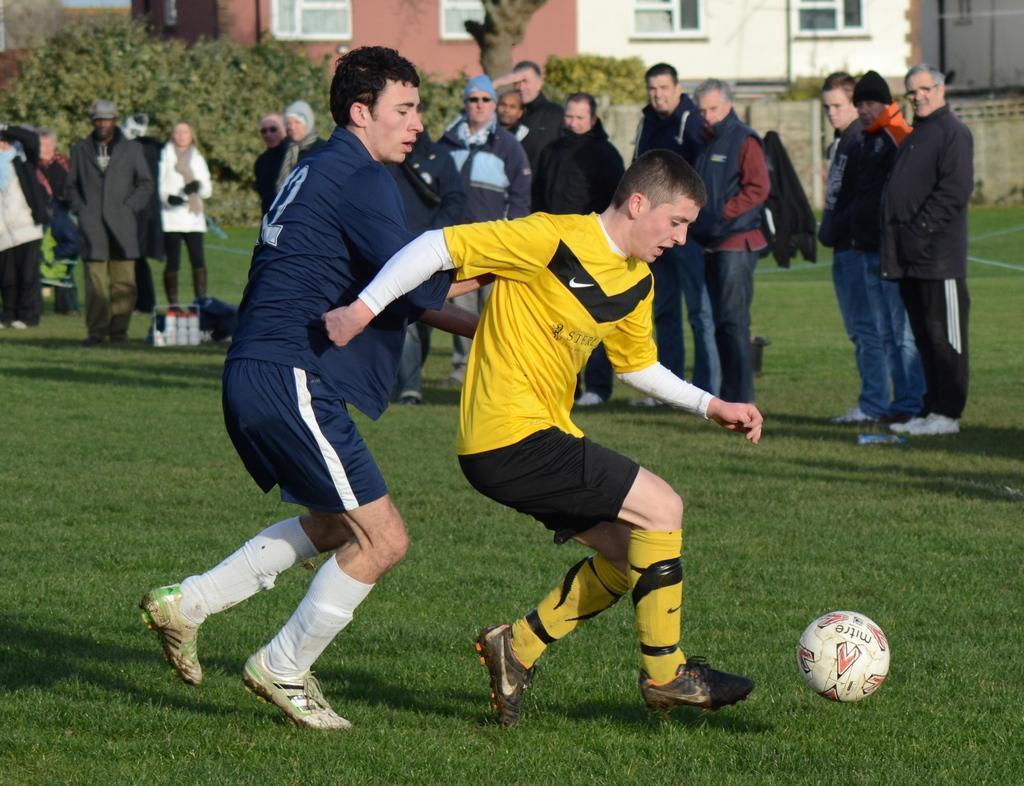Can you describe this image briefly? In this picture two guys are playing football ,one of the guy is blue color dress and the other is in yellow color. In the background we observe few people spectating these guys and there are two buildings in the background. 